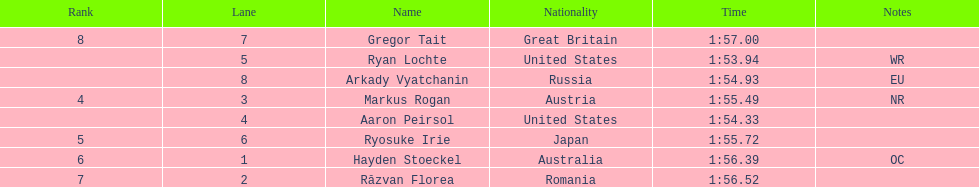Which country had the most medals in the competition? United States. 